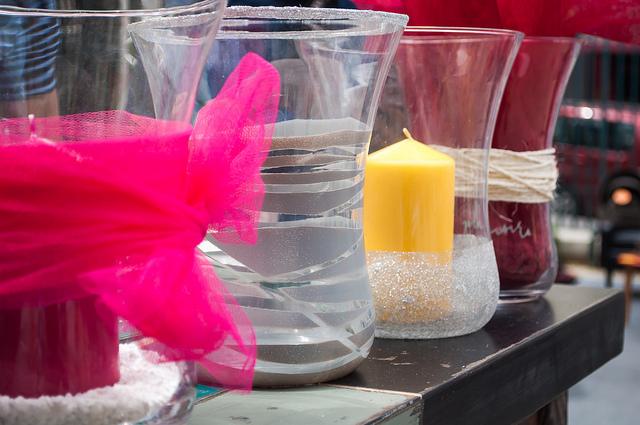Are these actually candle holders?
Quick response, please. No. What material are these containers made of?
Quick response, please. Glass. What is the orange drink?
Concise answer only. Candle. 